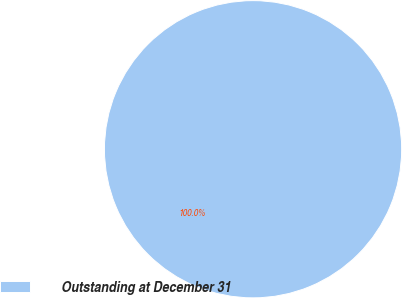Convert chart. <chart><loc_0><loc_0><loc_500><loc_500><pie_chart><fcel>Outstanding at December 31<nl><fcel>100.0%<nl></chart> 